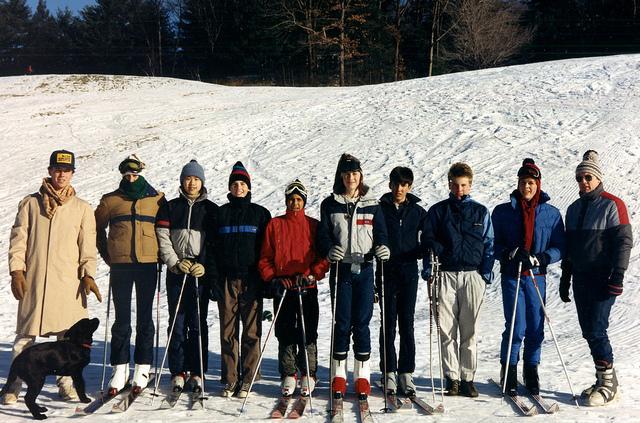What kind of pet is tagging along?
Write a very short answer. Dog. What gender is standing in the middle?
Give a very brief answer. Female. What are these people wearing on their feet?
Quick response, please. Skis. 